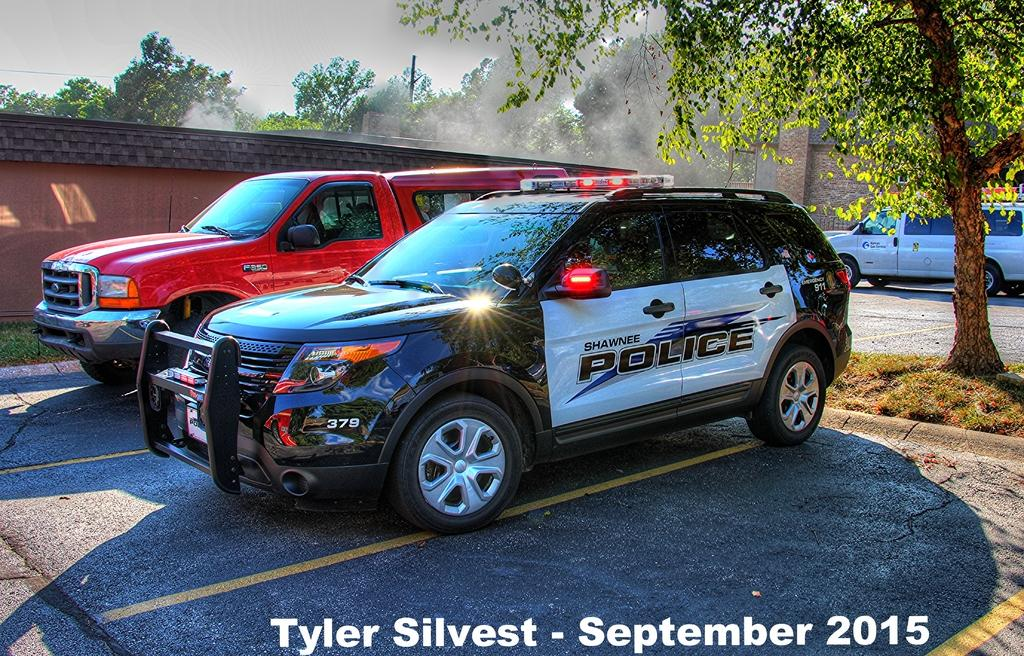What can be seen on the road in the image? There are vehicles on the road in the image. What type of vegetation is visible in the image? There is grass and trees visible in the image. What type of structures can be seen in the image? There are walls visible in the image. Is there any text present in the image? Yes, there is some text in the image. What is visible in the background of the image? The sky is visible in the background of the image. What type of instrument is being played by the team in the image? There is no team or instrument present in the image. How many spades are visible in the image? There are no spades visible in the image. 